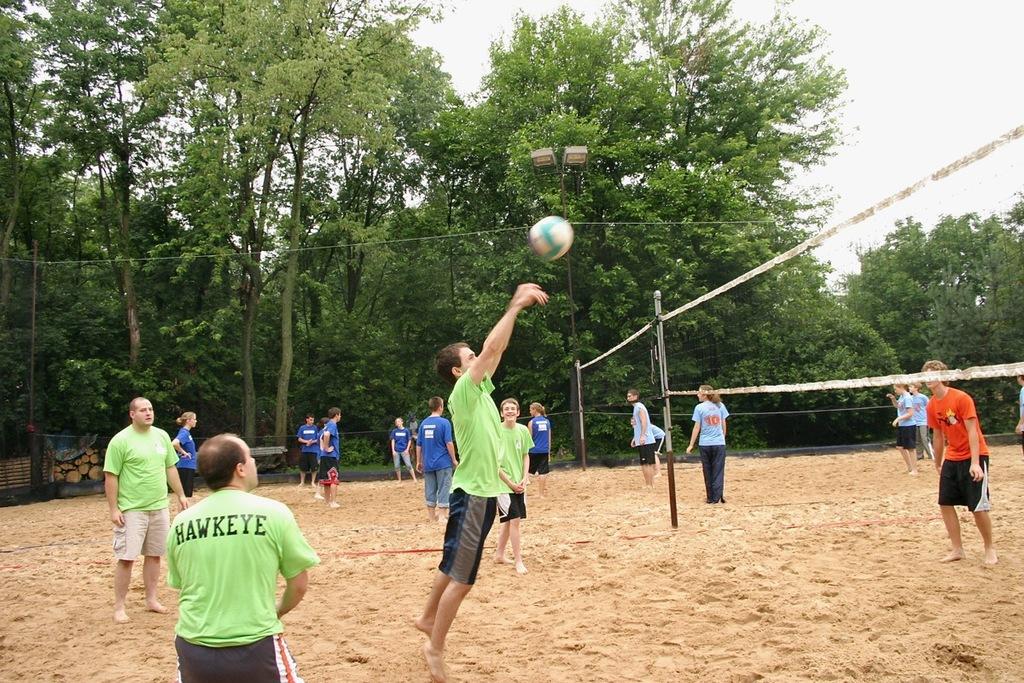Do all team members have nicknames?
Give a very brief answer. Unanswerable. What is the name of the man wearing green in the front?
Ensure brevity in your answer.  Hawkeye. 